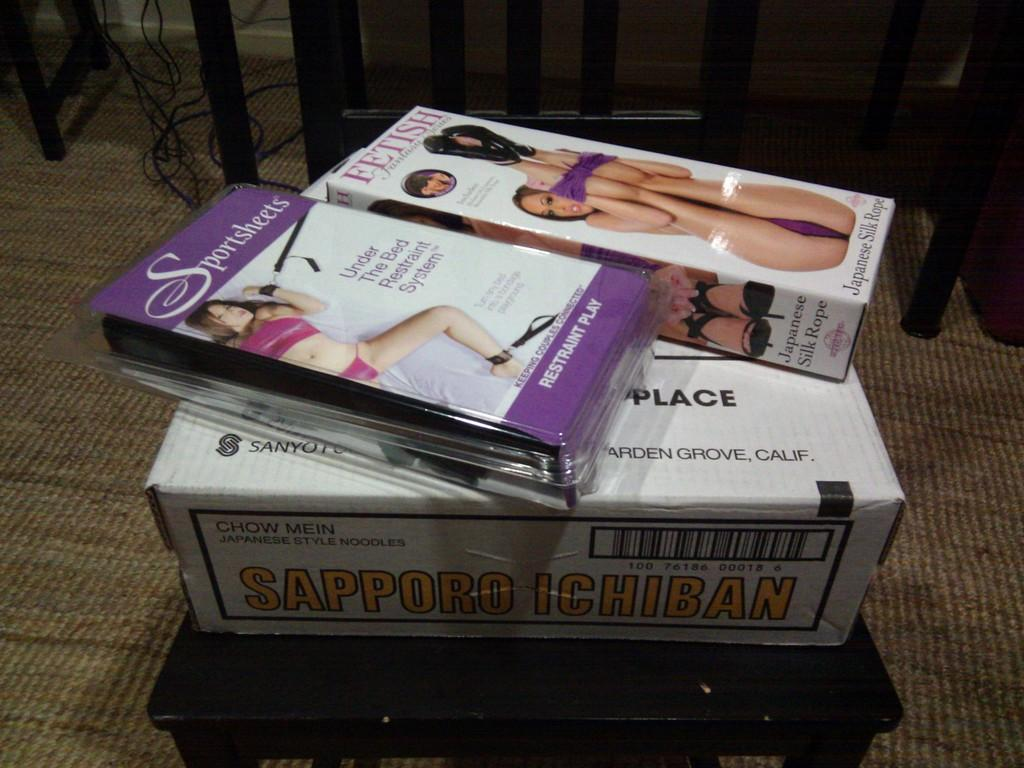<image>
Render a clear and concise summary of the photo. A stack of fetish DVDs and a box titled Sapporo Ichiban. 